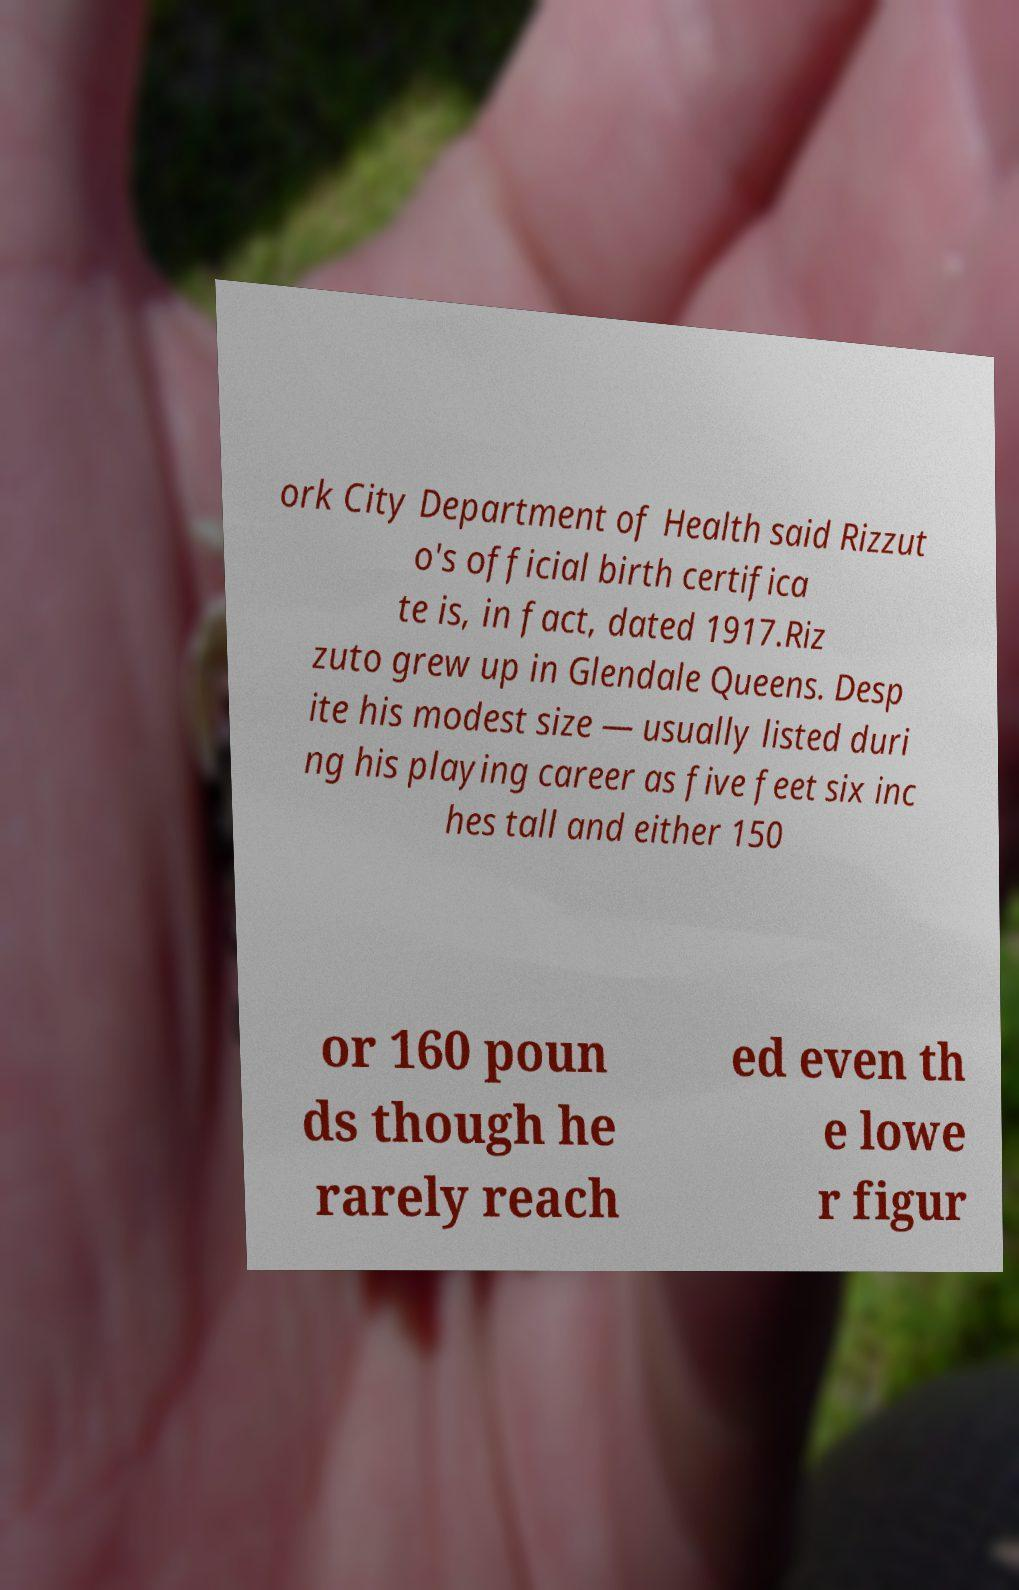Can you accurately transcribe the text from the provided image for me? ork City Department of Health said Rizzut o's official birth certifica te is, in fact, dated 1917.Riz zuto grew up in Glendale Queens. Desp ite his modest size — usually listed duri ng his playing career as five feet six inc hes tall and either 150 or 160 poun ds though he rarely reach ed even th e lowe r figur 